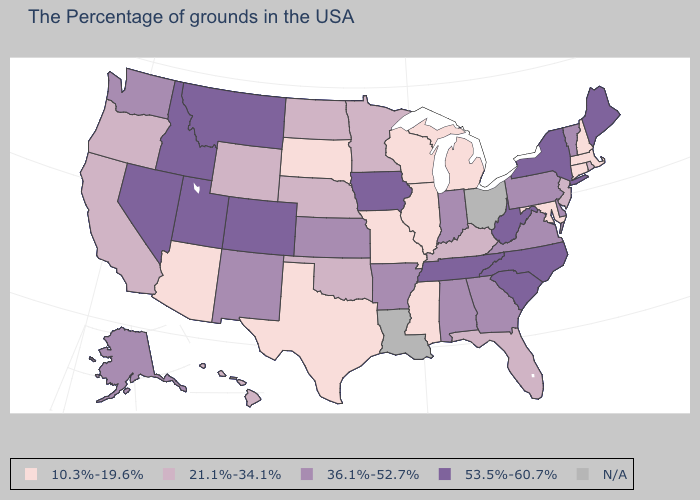Does Hawaii have the highest value in the USA?
Keep it brief. No. Which states have the lowest value in the USA?
Quick response, please. Massachusetts, New Hampshire, Connecticut, Maryland, Michigan, Wisconsin, Illinois, Mississippi, Missouri, Texas, South Dakota, Arizona. What is the highest value in the USA?
Keep it brief. 53.5%-60.7%. Among the states that border Maryland , which have the highest value?
Be succinct. West Virginia. Does the first symbol in the legend represent the smallest category?
Give a very brief answer. Yes. Name the states that have a value in the range 21.1%-34.1%?
Keep it brief. Rhode Island, New Jersey, Florida, Kentucky, Minnesota, Nebraska, Oklahoma, North Dakota, Wyoming, California, Oregon, Hawaii. How many symbols are there in the legend?
Answer briefly. 5. Name the states that have a value in the range 21.1%-34.1%?
Give a very brief answer. Rhode Island, New Jersey, Florida, Kentucky, Minnesota, Nebraska, Oklahoma, North Dakota, Wyoming, California, Oregon, Hawaii. What is the highest value in the USA?
Concise answer only. 53.5%-60.7%. Name the states that have a value in the range 21.1%-34.1%?
Short answer required. Rhode Island, New Jersey, Florida, Kentucky, Minnesota, Nebraska, Oklahoma, North Dakota, Wyoming, California, Oregon, Hawaii. Name the states that have a value in the range N/A?
Be succinct. Ohio, Louisiana. Name the states that have a value in the range 36.1%-52.7%?
Give a very brief answer. Vermont, Delaware, Pennsylvania, Virginia, Georgia, Indiana, Alabama, Arkansas, Kansas, New Mexico, Washington, Alaska. Name the states that have a value in the range 36.1%-52.7%?
Quick response, please. Vermont, Delaware, Pennsylvania, Virginia, Georgia, Indiana, Alabama, Arkansas, Kansas, New Mexico, Washington, Alaska. What is the highest value in states that border Vermont?
Short answer required. 53.5%-60.7%. 